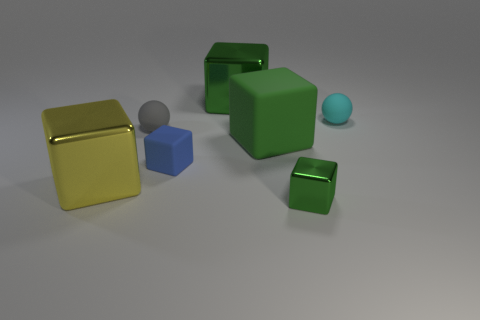Add 3 big objects. How many objects exist? 10 Subtract all blue cubes. How many cubes are left? 4 Subtract all big yellow shiny cubes. How many cubes are left? 4 Subtract 1 cyan spheres. How many objects are left? 6 Subtract all cubes. How many objects are left? 2 Subtract 2 cubes. How many cubes are left? 3 Subtract all brown blocks. Subtract all blue cylinders. How many blocks are left? 5 Subtract all brown blocks. How many cyan balls are left? 1 Subtract all blue cubes. Subtract all large yellow shiny cubes. How many objects are left? 5 Add 7 large metallic cubes. How many large metallic cubes are left? 9 